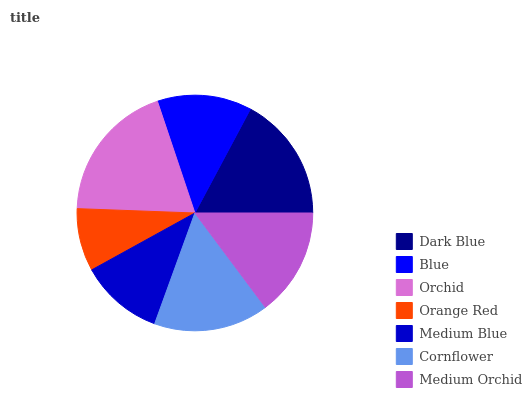Is Orange Red the minimum?
Answer yes or no. Yes. Is Orchid the maximum?
Answer yes or no. Yes. Is Blue the minimum?
Answer yes or no. No. Is Blue the maximum?
Answer yes or no. No. Is Dark Blue greater than Blue?
Answer yes or no. Yes. Is Blue less than Dark Blue?
Answer yes or no. Yes. Is Blue greater than Dark Blue?
Answer yes or no. No. Is Dark Blue less than Blue?
Answer yes or no. No. Is Medium Orchid the high median?
Answer yes or no. Yes. Is Medium Orchid the low median?
Answer yes or no. Yes. Is Blue the high median?
Answer yes or no. No. Is Orange Red the low median?
Answer yes or no. No. 